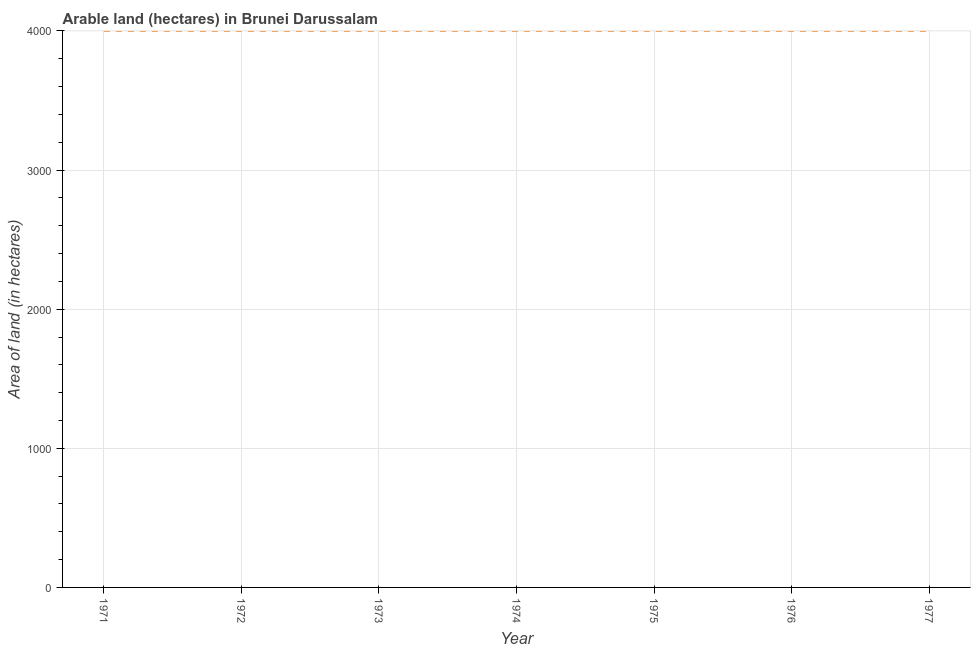What is the area of land in 1972?
Ensure brevity in your answer.  4000. Across all years, what is the maximum area of land?
Make the answer very short. 4000. Across all years, what is the minimum area of land?
Your answer should be very brief. 4000. In which year was the area of land maximum?
Offer a very short reply. 1971. In which year was the area of land minimum?
Your answer should be very brief. 1971. What is the sum of the area of land?
Provide a short and direct response. 2.80e+04. What is the average area of land per year?
Ensure brevity in your answer.  4000. What is the median area of land?
Your answer should be compact. 4000. In how many years, is the area of land greater than 1400 hectares?
Give a very brief answer. 7. Is the area of land in 1971 less than that in 1977?
Provide a succinct answer. No. What is the difference between two consecutive major ticks on the Y-axis?
Give a very brief answer. 1000. Are the values on the major ticks of Y-axis written in scientific E-notation?
Keep it short and to the point. No. Does the graph contain grids?
Offer a terse response. Yes. What is the title of the graph?
Keep it short and to the point. Arable land (hectares) in Brunei Darussalam. What is the label or title of the Y-axis?
Give a very brief answer. Area of land (in hectares). What is the Area of land (in hectares) of 1971?
Keep it short and to the point. 4000. What is the Area of land (in hectares) of 1972?
Ensure brevity in your answer.  4000. What is the Area of land (in hectares) in 1973?
Your answer should be compact. 4000. What is the Area of land (in hectares) of 1974?
Give a very brief answer. 4000. What is the Area of land (in hectares) in 1975?
Make the answer very short. 4000. What is the Area of land (in hectares) in 1976?
Offer a terse response. 4000. What is the Area of land (in hectares) of 1977?
Offer a terse response. 4000. What is the difference between the Area of land (in hectares) in 1971 and 1973?
Offer a terse response. 0. What is the difference between the Area of land (in hectares) in 1971 and 1975?
Provide a succinct answer. 0. What is the difference between the Area of land (in hectares) in 1971 and 1976?
Ensure brevity in your answer.  0. What is the difference between the Area of land (in hectares) in 1972 and 1973?
Provide a short and direct response. 0. What is the difference between the Area of land (in hectares) in 1972 and 1974?
Provide a short and direct response. 0. What is the difference between the Area of land (in hectares) in 1972 and 1976?
Your response must be concise. 0. What is the difference between the Area of land (in hectares) in 1972 and 1977?
Make the answer very short. 0. What is the difference between the Area of land (in hectares) in 1973 and 1974?
Your answer should be very brief. 0. What is the difference between the Area of land (in hectares) in 1973 and 1975?
Offer a very short reply. 0. What is the difference between the Area of land (in hectares) in 1974 and 1975?
Your response must be concise. 0. What is the difference between the Area of land (in hectares) in 1975 and 1977?
Provide a succinct answer. 0. What is the difference between the Area of land (in hectares) in 1976 and 1977?
Keep it short and to the point. 0. What is the ratio of the Area of land (in hectares) in 1973 to that in 1974?
Ensure brevity in your answer.  1. What is the ratio of the Area of land (in hectares) in 1974 to that in 1977?
Give a very brief answer. 1. What is the ratio of the Area of land (in hectares) in 1975 to that in 1976?
Make the answer very short. 1. 